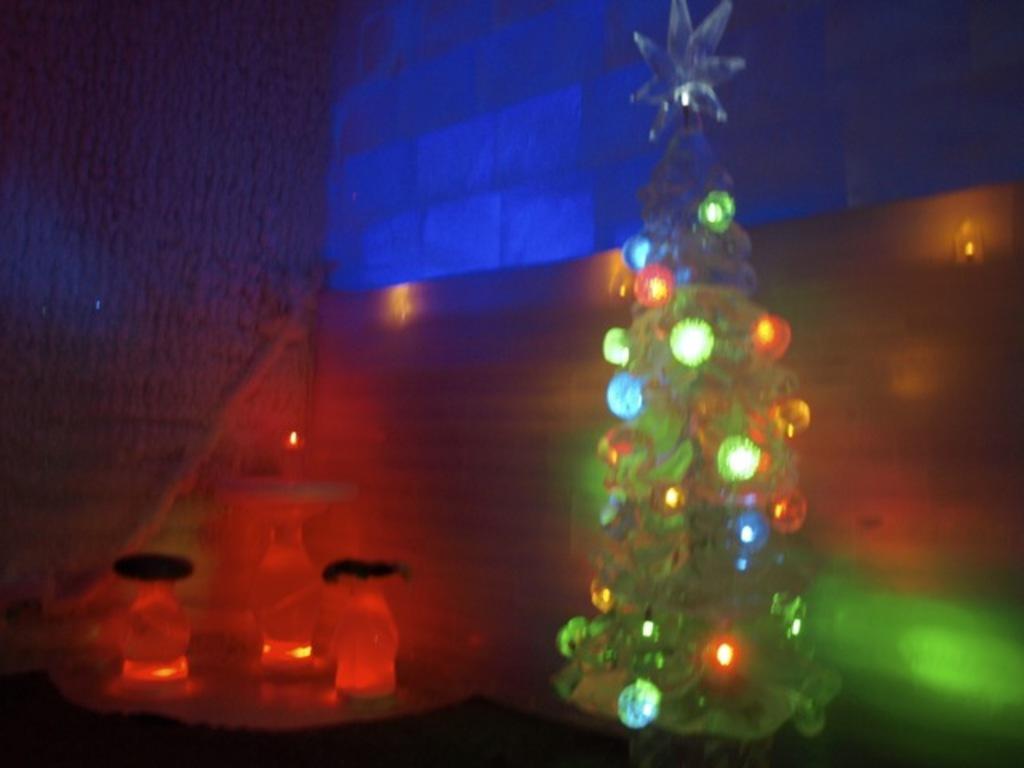Can you describe this image briefly? In the image there are few decorative things with lights. Behind them there are walls with lights. 